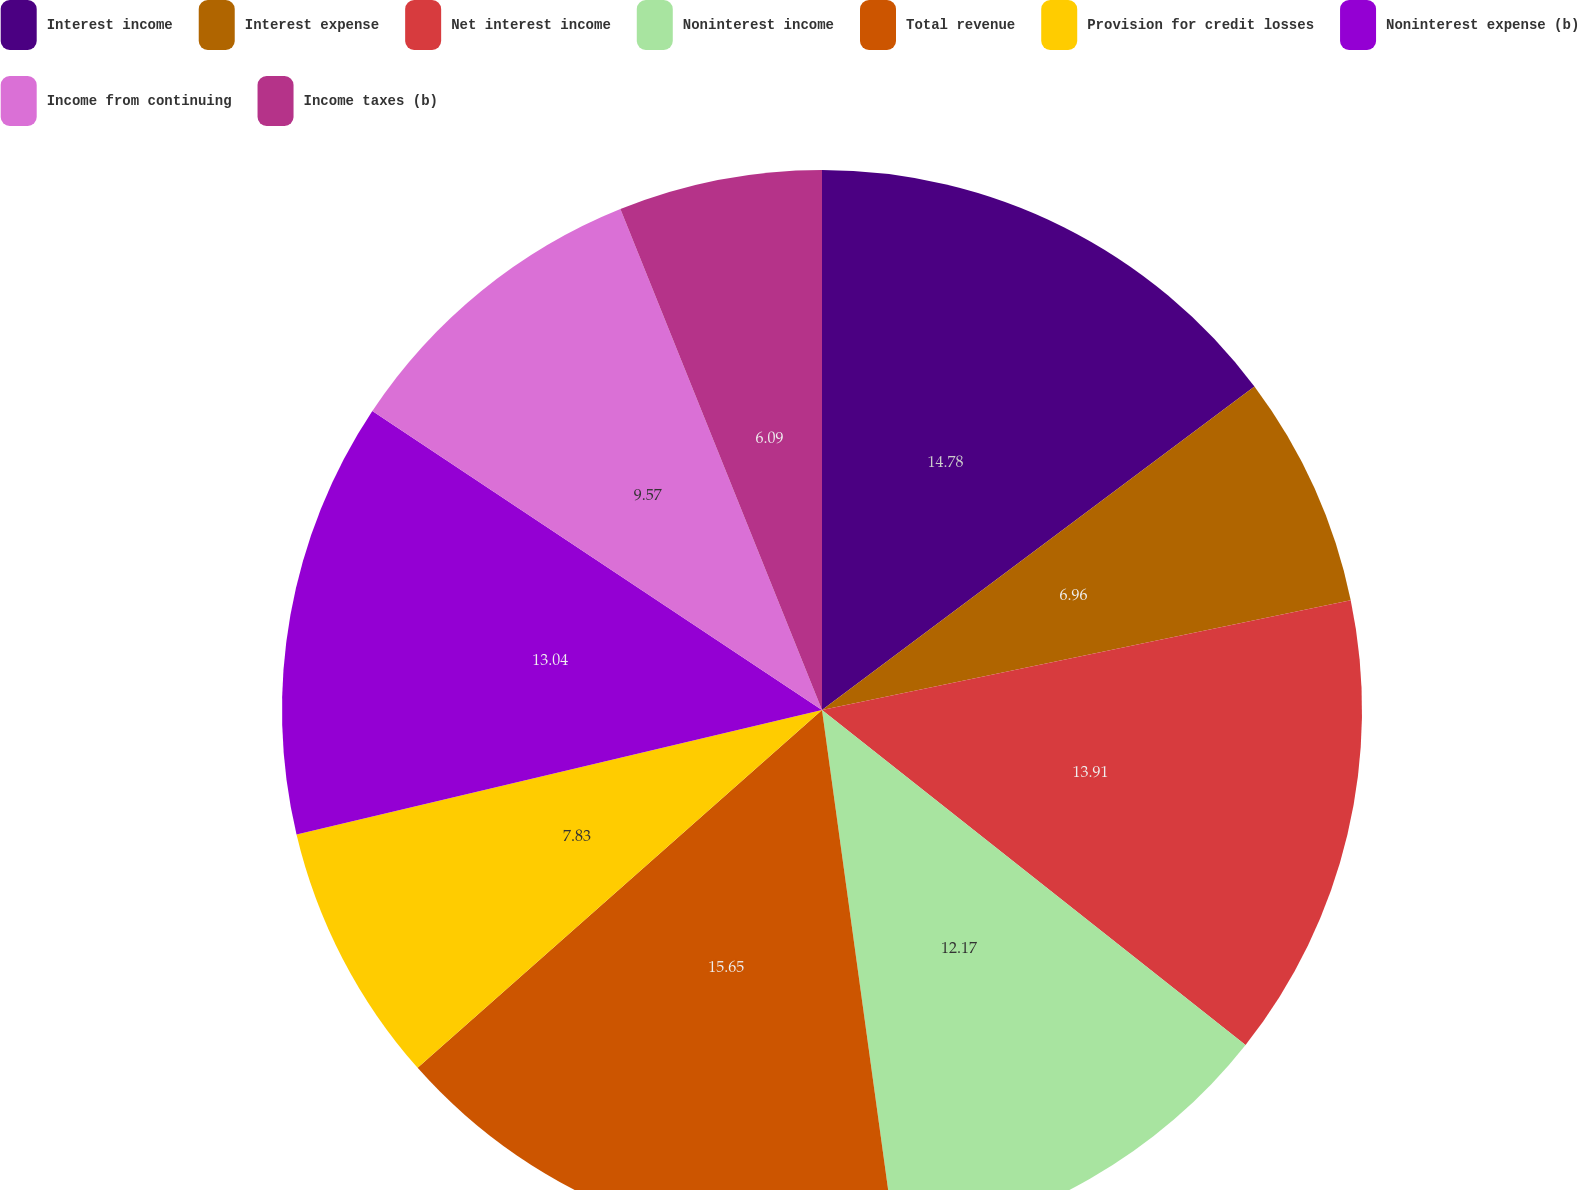Convert chart. <chart><loc_0><loc_0><loc_500><loc_500><pie_chart><fcel>Interest income<fcel>Interest expense<fcel>Net interest income<fcel>Noninterest income<fcel>Total revenue<fcel>Provision for credit losses<fcel>Noninterest expense (b)<fcel>Income from continuing<fcel>Income taxes (b)<nl><fcel>14.78%<fcel>6.96%<fcel>13.91%<fcel>12.17%<fcel>15.65%<fcel>7.83%<fcel>13.04%<fcel>9.57%<fcel>6.09%<nl></chart> 